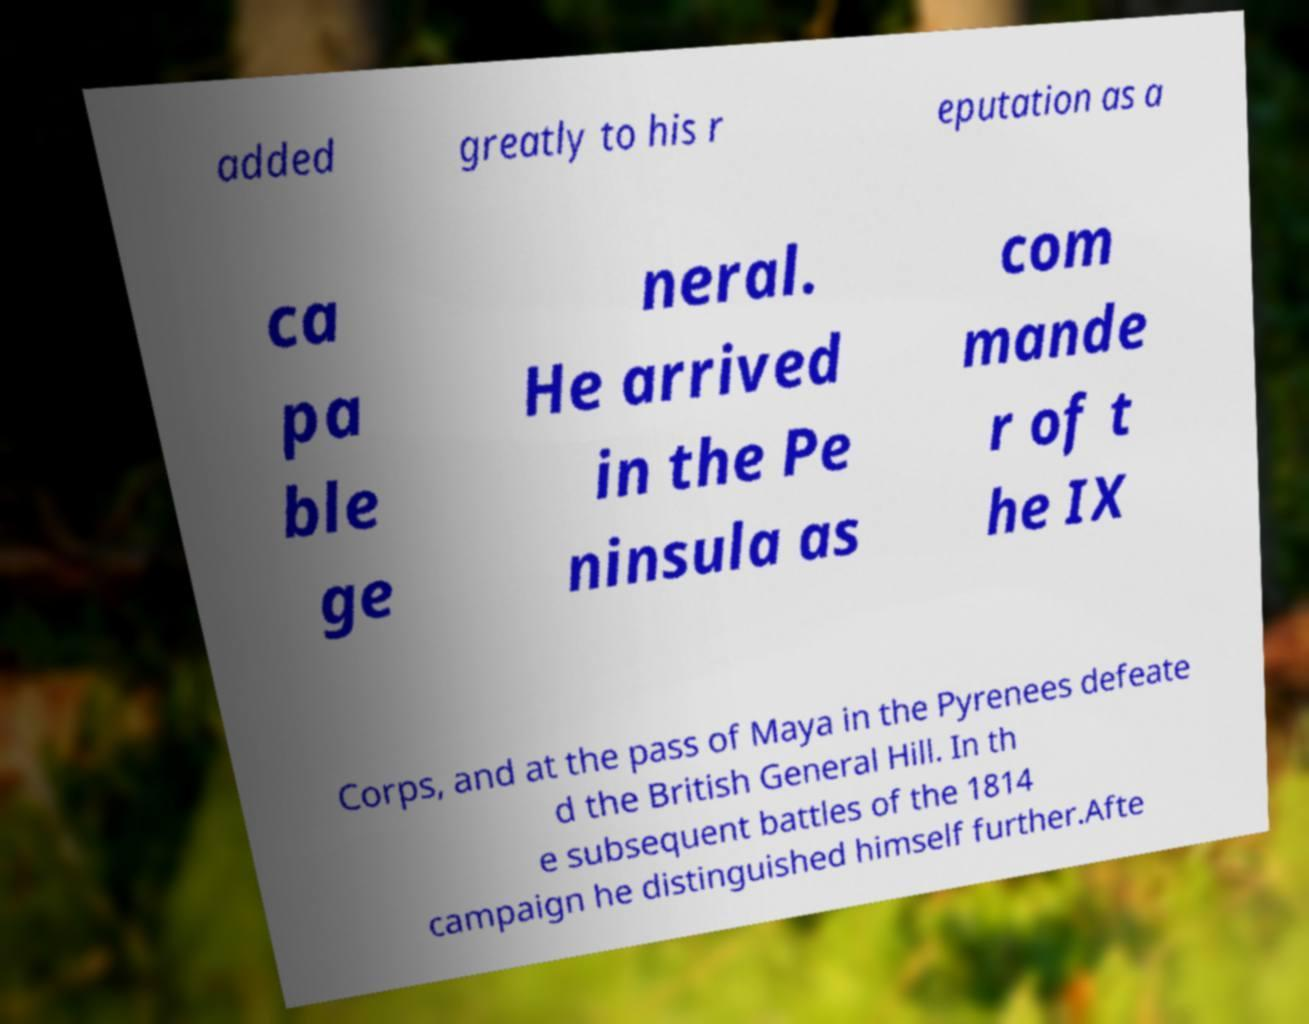Please identify and transcribe the text found in this image. added greatly to his r eputation as a ca pa ble ge neral. He arrived in the Pe ninsula as com mande r of t he IX Corps, and at the pass of Maya in the Pyrenees defeate d the British General Hill. In th e subsequent battles of the 1814 campaign he distinguished himself further.Afte 